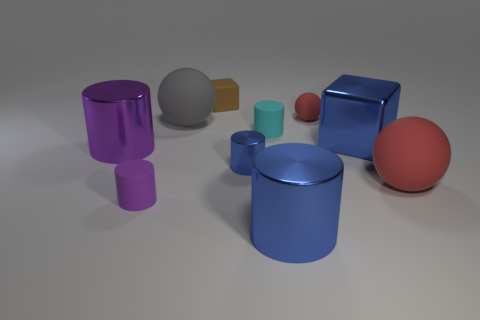Subtract all blue metal cylinders. How many cylinders are left? 3 Subtract all red balls. How many balls are left? 1 Subtract all balls. How many objects are left? 7 Subtract 2 spheres. How many spheres are left? 1 Subtract all purple balls. Subtract all red cubes. How many balls are left? 3 Subtract all purple blocks. How many brown balls are left? 0 Subtract all large red rubber objects. Subtract all large red things. How many objects are left? 8 Add 6 large purple cylinders. How many large purple cylinders are left? 7 Add 1 small gray cubes. How many small gray cubes exist? 1 Subtract 0 brown balls. How many objects are left? 10 